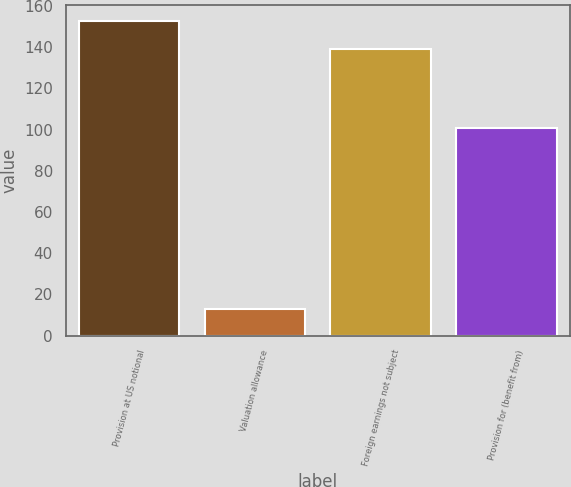Convert chart. <chart><loc_0><loc_0><loc_500><loc_500><bar_chart><fcel>Provision at US notional<fcel>Valuation allowance<fcel>Foreign earnings not subject<fcel>Provision for (benefit from)<nl><fcel>152.7<fcel>13<fcel>139<fcel>101<nl></chart> 